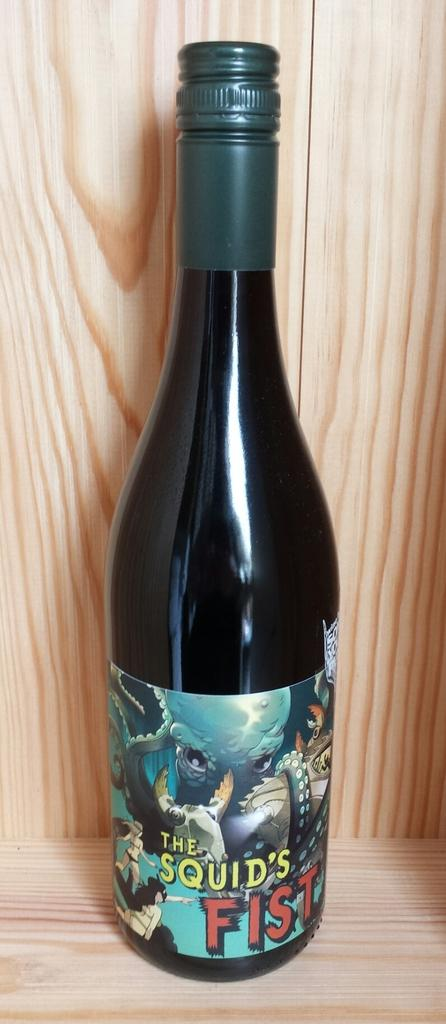<image>
Render a clear and concise summary of the photo. A bottle of The Squid's Fist with images of fish on the label. 